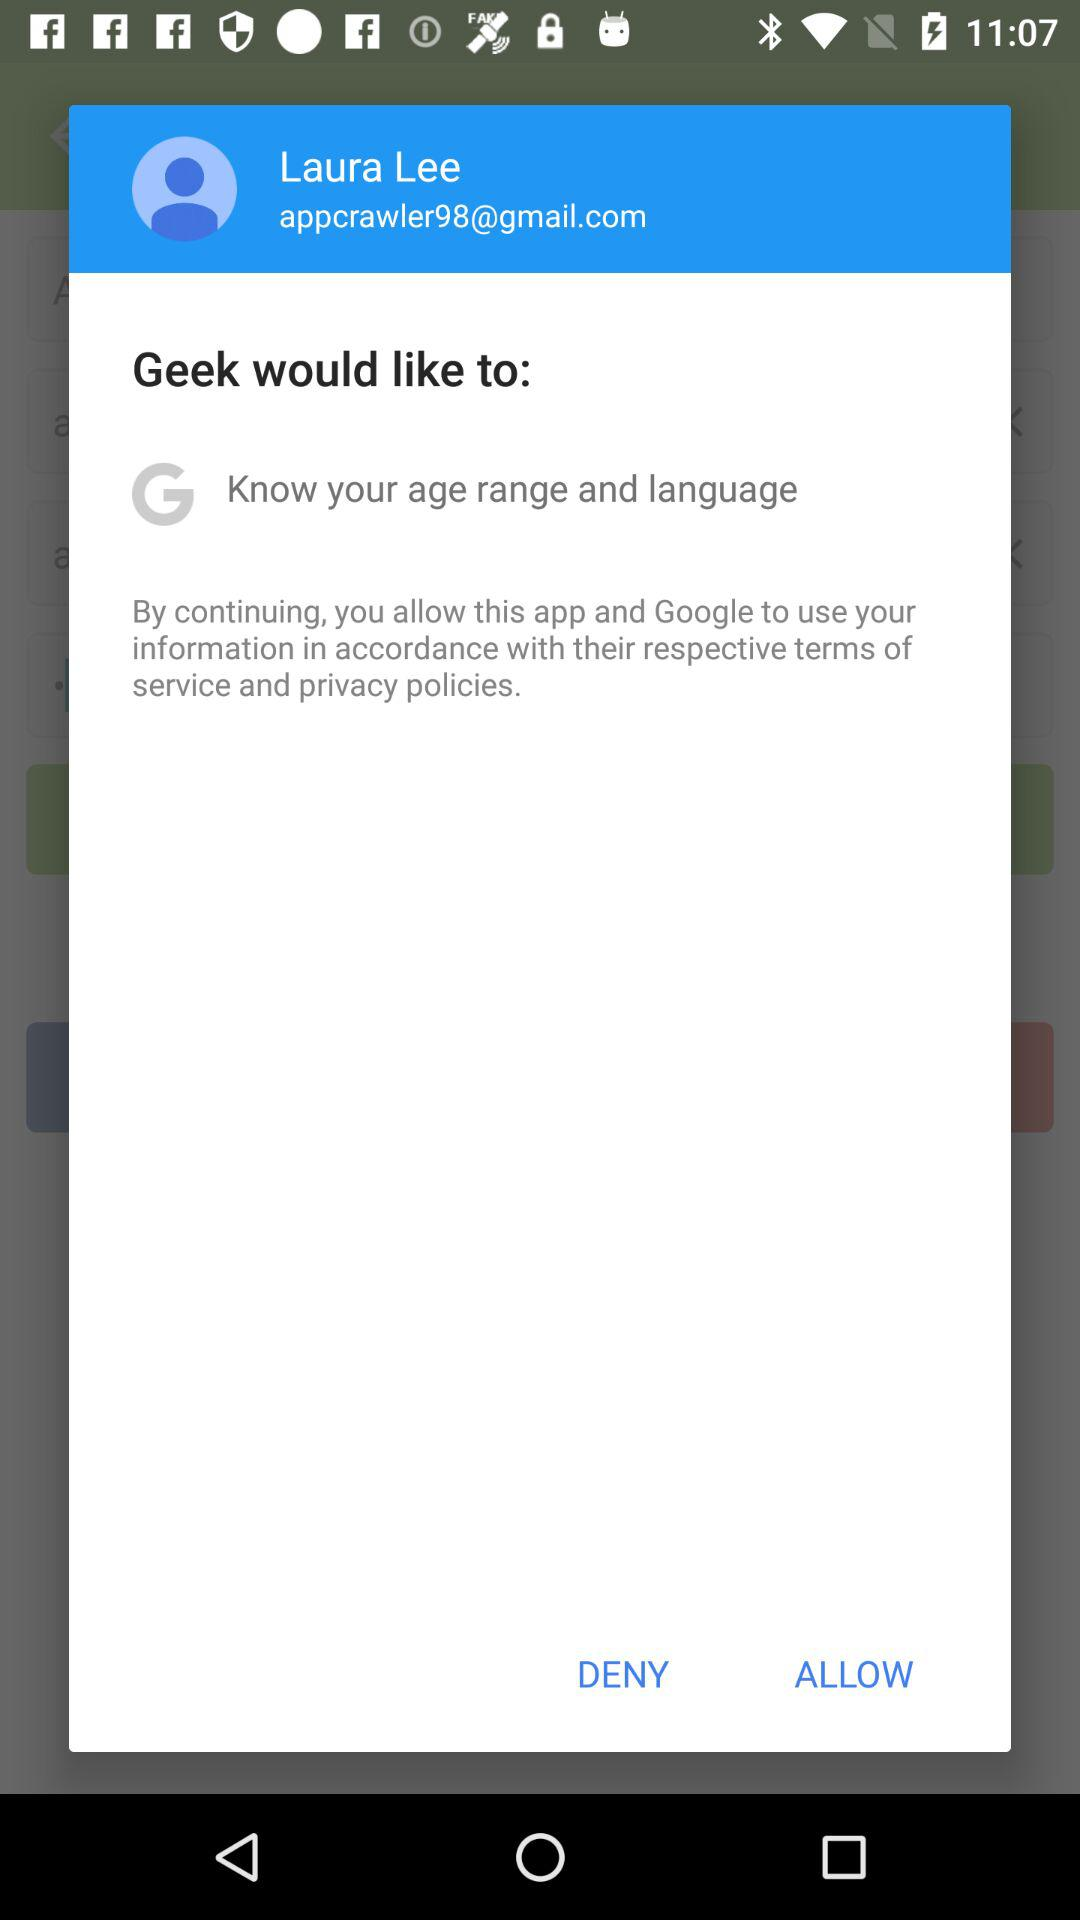What is the email address? The email address is appcrawler98@gmail.com. 